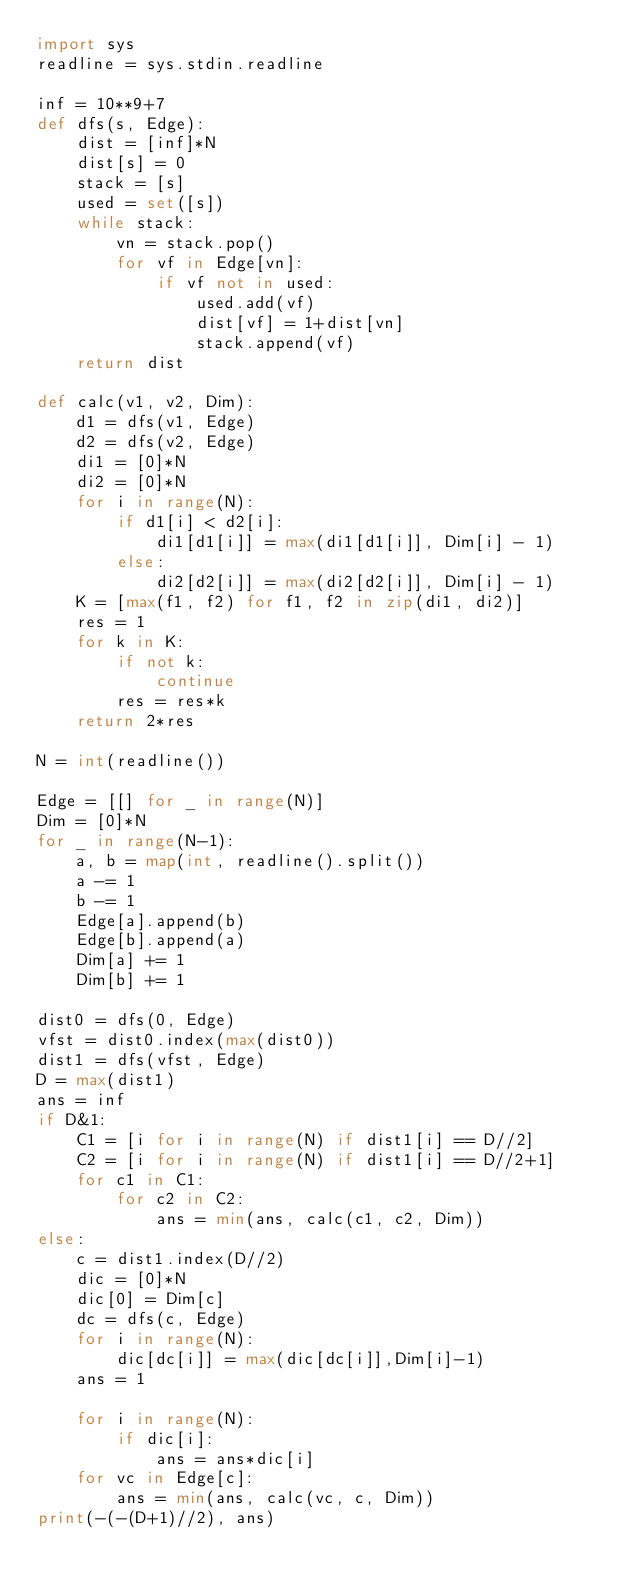<code> <loc_0><loc_0><loc_500><loc_500><_Python_>import sys
readline = sys.stdin.readline

inf = 10**9+7
def dfs(s, Edge):
    dist = [inf]*N
    dist[s] = 0
    stack = [s]
    used = set([s])
    while stack:
        vn = stack.pop()
        for vf in Edge[vn]:
            if vf not in used:
                used.add(vf)
                dist[vf] = 1+dist[vn]
                stack.append(vf)
    return dist                

def calc(v1, v2, Dim):
    d1 = dfs(v1, Edge)
    d2 = dfs(v2, Edge)
    di1 = [0]*N
    di2 = [0]*N
    for i in range(N):
        if d1[i] < d2[i]:
            di1[d1[i]] = max(di1[d1[i]], Dim[i] - 1)
        else:
            di2[d2[i]] = max(di2[d2[i]], Dim[i] - 1)
    K = [max(f1, f2) for f1, f2 in zip(di1, di2)]
    res = 1
    for k in K:
        if not k:
            continue
        res = res*k
    return 2*res

N = int(readline())

Edge = [[] for _ in range(N)]
Dim = [0]*N
for _ in range(N-1):
    a, b = map(int, readline().split())
    a -= 1
    b -= 1
    Edge[a].append(b)
    Edge[b].append(a)
    Dim[a] += 1
    Dim[b] += 1

dist0 = dfs(0, Edge)
vfst = dist0.index(max(dist0))
dist1 = dfs(vfst, Edge)
D = max(dist1)
ans = inf
if D&1:
    C1 = [i for i in range(N) if dist1[i] == D//2]
    C2 = [i for i in range(N) if dist1[i] == D//2+1]
    for c1 in C1:
        for c2 in C2:
            ans = min(ans, calc(c1, c2, Dim))
else:
    c = dist1.index(D//2)
    dic = [0]*N
    dic[0] = Dim[c]
    dc = dfs(c, Edge)
    for i in range(N):
        dic[dc[i]] = max(dic[dc[i]],Dim[i]-1)
    ans = 1
    
    for i in range(N):
        if dic[i]:
            ans = ans*dic[i]
    for vc in Edge[c]:
        ans = min(ans, calc(vc, c, Dim))
print(-(-(D+1)//2), ans)</code> 